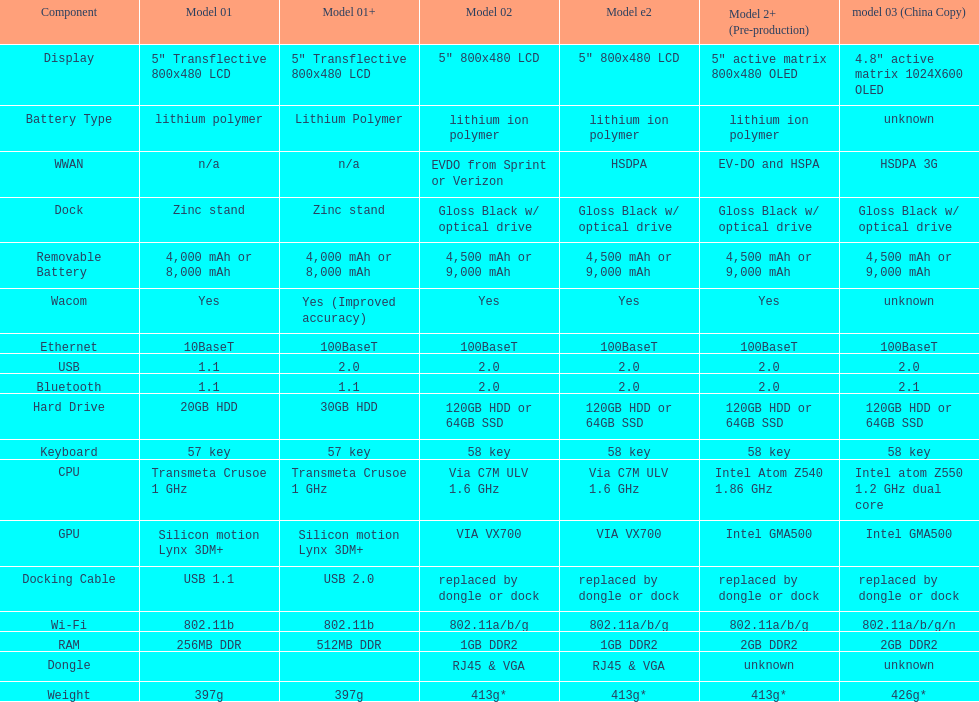Help me parse the entirety of this table. {'header': ['Component', 'Model 01', 'Model 01+', 'Model 02', 'Model e2', 'Model 2+ (Pre-production)', 'model 03 (China Copy)'], 'rows': [['Display', '5" Transflective 800x480 LCD', '5" Transflective 800x480 LCD', '5" 800x480 LCD', '5" 800x480 LCD', '5" active matrix 800x480 OLED', '4.8" active matrix 1024X600 OLED'], ['Battery Type', 'lithium polymer', 'Lithium Polymer', 'lithium ion polymer', 'lithium ion polymer', 'lithium ion polymer', 'unknown'], ['WWAN', 'n/a', 'n/a', 'EVDO from Sprint or Verizon', 'HSDPA', 'EV-DO and HSPA', 'HSDPA 3G'], ['Dock', 'Zinc stand', 'Zinc stand', 'Gloss Black w/ optical drive', 'Gloss Black w/ optical drive', 'Gloss Black w/ optical drive', 'Gloss Black w/ optical drive'], ['Removable Battery', '4,000 mAh or 8,000 mAh', '4,000 mAh or 8,000 mAh', '4,500 mAh or 9,000 mAh', '4,500 mAh or 9,000 mAh', '4,500 mAh or 9,000 mAh', '4,500 mAh or 9,000 mAh'], ['Wacom', 'Yes', 'Yes (Improved accuracy)', 'Yes', 'Yes', 'Yes', 'unknown'], ['Ethernet', '10BaseT', '100BaseT', '100BaseT', '100BaseT', '100BaseT', '100BaseT'], ['USB', '1.1', '2.0', '2.0', '2.0', '2.0', '2.0'], ['Bluetooth', '1.1', '1.1', '2.0', '2.0', '2.0', '2.1'], ['Hard Drive', '20GB HDD', '30GB HDD', '120GB HDD or 64GB SSD', '120GB HDD or 64GB SSD', '120GB HDD or 64GB SSD', '120GB HDD or 64GB SSD'], ['Keyboard', '57 key', '57 key', '58 key', '58 key', '58 key', '58 key'], ['CPU', 'Transmeta Crusoe 1\xa0GHz', 'Transmeta Crusoe 1\xa0GHz', 'Via C7M ULV 1.6\xa0GHz', 'Via C7M ULV 1.6\xa0GHz', 'Intel Atom Z540 1.86\xa0GHz', 'Intel atom Z550 1.2\xa0GHz dual core'], ['GPU', 'Silicon motion Lynx 3DM+', 'Silicon motion Lynx 3DM+', 'VIA VX700', 'VIA VX700', 'Intel GMA500', 'Intel GMA500'], ['Docking Cable', 'USB 1.1', 'USB 2.0', 'replaced by dongle or dock', 'replaced by dongle or dock', 'replaced by dongle or dock', 'replaced by dongle or dock'], ['Wi-Fi', '802.11b', '802.11b', '802.11a/b/g', '802.11a/b/g', '802.11a/b/g', '802.11a/b/g/n'], ['RAM', '256MB DDR', '512MB DDR', '1GB DDR2', '1GB DDR2', '2GB DDR2', '2GB DDR2'], ['Dongle', '', '', 'RJ45 & VGA', 'RJ45 & VGA', 'unknown', 'unknown'], ['Weight', '397g', '397g', '413g*', '413g*', '413g*', '426g*']]} How many models have 1.6ghz? 2. 